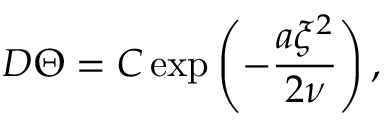Convert formula to latex. <formula><loc_0><loc_0><loc_500><loc_500>D \Theta = C \exp \left ( - \frac { a \xi ^ { 2 } } { 2 \nu } \right ) ,</formula> 